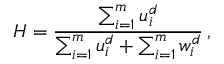<formula> <loc_0><loc_0><loc_500><loc_500>H = { \frac { \sum _ { i = 1 } ^ { m } { u _ { i } ^ { d } } } { \sum _ { i = 1 } ^ { m } { u _ { i } ^ { d } } + \sum _ { i = 1 } ^ { m } { w _ { i } ^ { d } } } } \, ,</formula> 